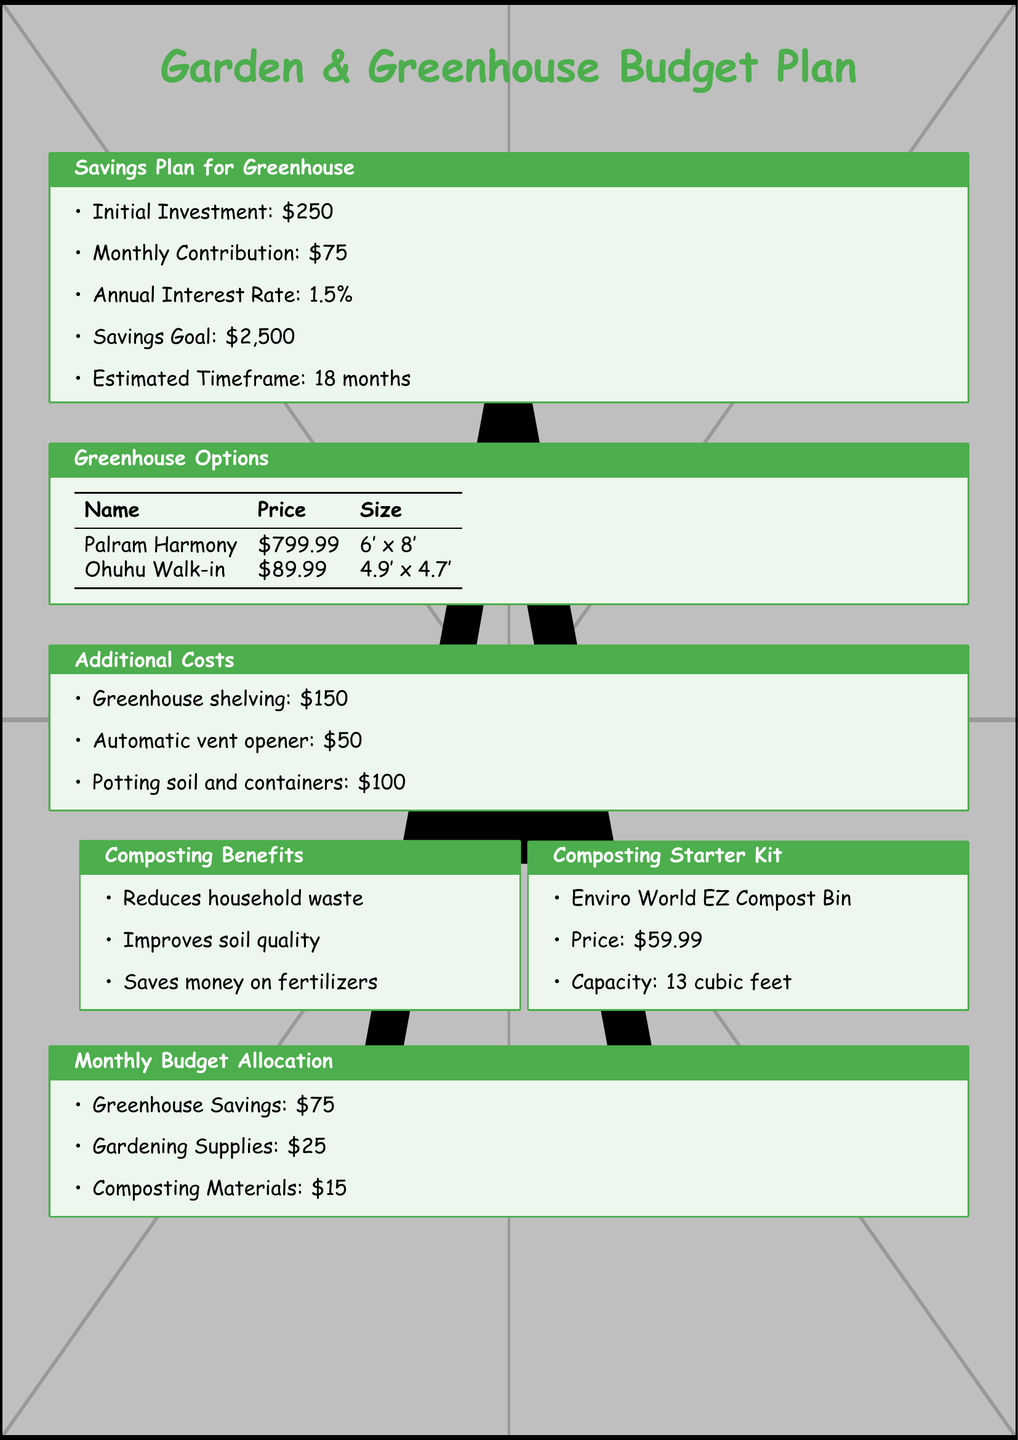what is the initial investment for the greenhouse? The initial investment amount is specified in the savings plan section of the document.
Answer: $250 how much is the monthly contribution? The document lists the monthly contribution in the savings plan.
Answer: $75 what is the annual interest rate? The annual interest rate is mentioned in the savings plan section.
Answer: 1.5% what is the savings goal? The savings goal is specified in the document under the savings plan section.
Answer: $2,500 how long is the estimated timeframe to reach the savings goal? The estimated timeframe is defined in the savings plan section.
Answer: 18 months what is the total cost for the Palram Harmony greenhouse? The cost of the Palram Harmony greenhouse is mentioned in the greenhouse options.
Answer: $799.99 what is the total budget for gardening supplies? The monthly budget allocation section of the document lists this amount.
Answer: $25 what is the cost of the Enviro World EZ Compost Bin? The price of the compost bin is detailed in the composting starter kit section.
Answer: $59.99 how much is allocated for composting materials each month? The monthly budget allocation specifies the amount for composting materials.
Answer: $15 